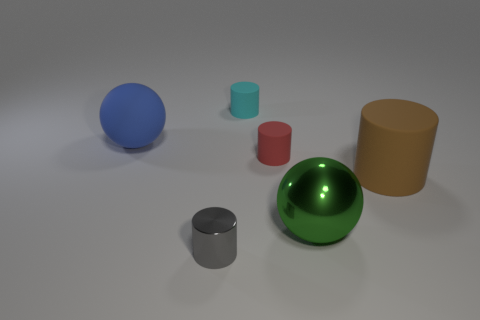Subtract all small cyan cylinders. How many cylinders are left? 3 Add 3 cyan things. How many objects exist? 9 Subtract all balls. How many objects are left? 4 Subtract 1 cylinders. How many cylinders are left? 3 Subtract all red spheres. Subtract all gray cylinders. How many spheres are left? 2 Subtract all gray cylinders. How many blue balls are left? 1 Subtract all brown rubber cylinders. Subtract all large spheres. How many objects are left? 3 Add 6 red cylinders. How many red cylinders are left? 7 Add 3 large shiny spheres. How many large shiny spheres exist? 4 Subtract all blue spheres. How many spheres are left? 1 